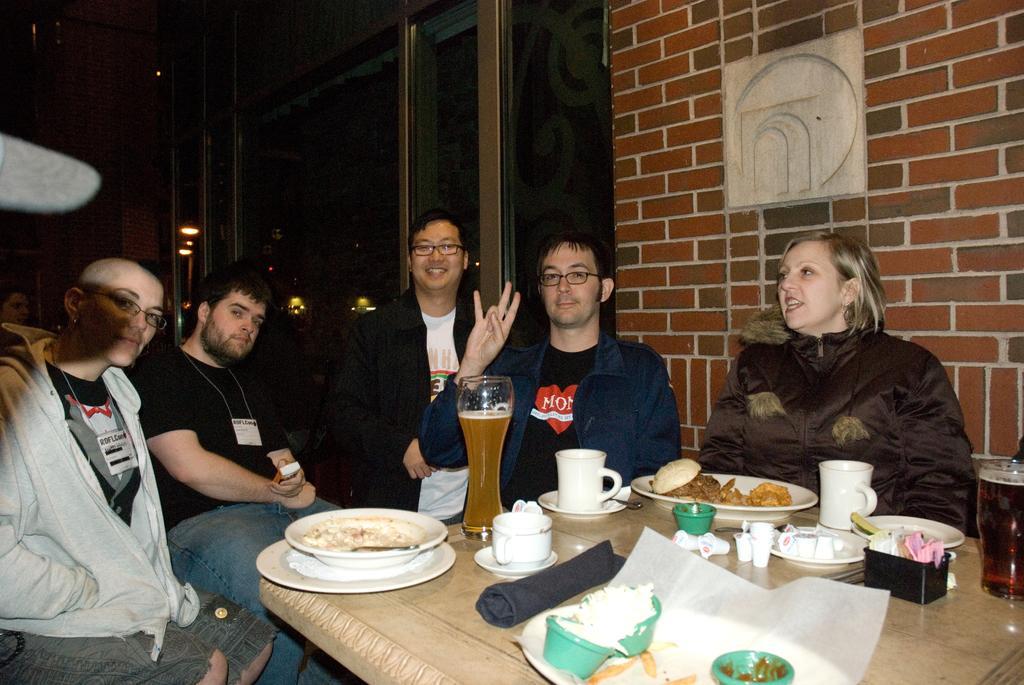Please provide a concise description of this image. In this image there are people sitting on chairs. There is a table on which there are glasses, plates and other objects. To the right side of the image there is a wall. 